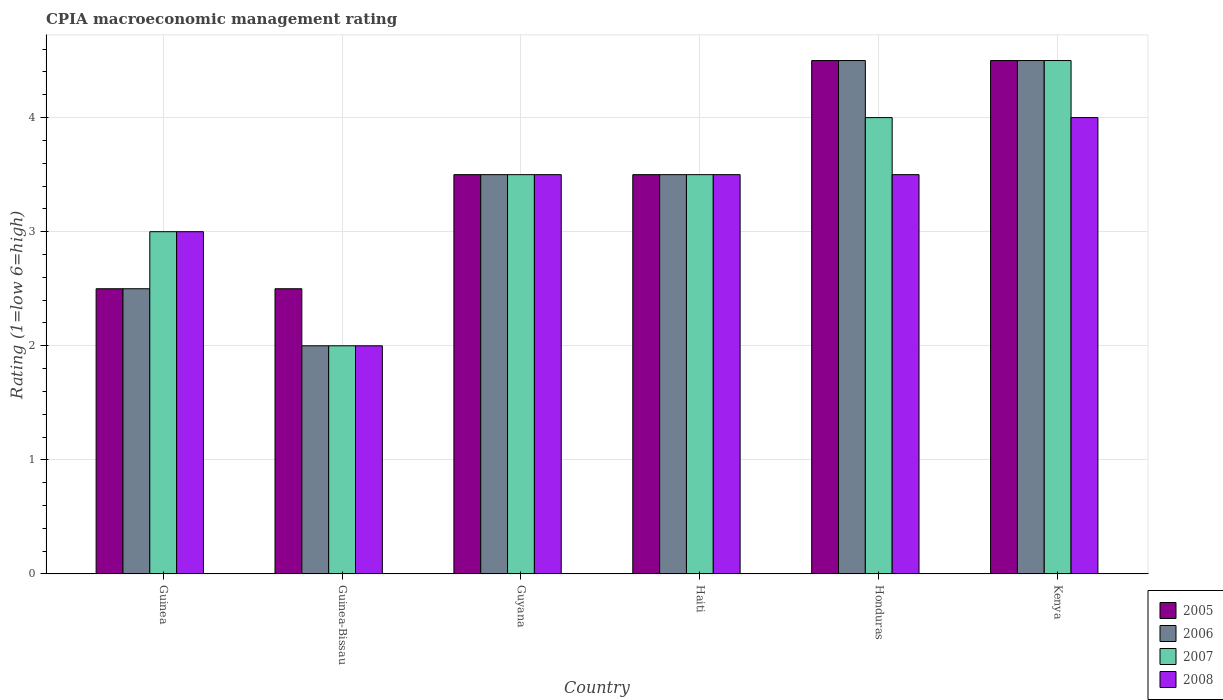Are the number of bars per tick equal to the number of legend labels?
Ensure brevity in your answer.  Yes. Are the number of bars on each tick of the X-axis equal?
Your response must be concise. Yes. What is the label of the 1st group of bars from the left?
Your answer should be very brief. Guinea. In how many cases, is the number of bars for a given country not equal to the number of legend labels?
Make the answer very short. 0. What is the CPIA rating in 2006 in Guinea-Bissau?
Your response must be concise. 2. Across all countries, what is the maximum CPIA rating in 2006?
Your answer should be very brief. 4.5. In which country was the CPIA rating in 2007 maximum?
Your answer should be very brief. Kenya. In which country was the CPIA rating in 2006 minimum?
Make the answer very short. Guinea-Bissau. What is the total CPIA rating in 2005 in the graph?
Offer a terse response. 21. What is the average CPIA rating in 2006 per country?
Make the answer very short. 3.42. In how many countries, is the CPIA rating in 2006 greater than 2?
Make the answer very short. 5. What is the ratio of the CPIA rating in 2005 in Haiti to that in Honduras?
Your answer should be compact. 0.78. Is the CPIA rating in 2008 in Guyana less than that in Kenya?
Ensure brevity in your answer.  Yes. Is the sum of the CPIA rating in 2007 in Guinea-Bissau and Guyana greater than the maximum CPIA rating in 2008 across all countries?
Provide a short and direct response. Yes. What does the 3rd bar from the left in Guyana represents?
Ensure brevity in your answer.  2007. What does the 3rd bar from the right in Guinea represents?
Give a very brief answer. 2006. Are all the bars in the graph horizontal?
Your answer should be very brief. No. Does the graph contain any zero values?
Provide a short and direct response. No. What is the title of the graph?
Your answer should be compact. CPIA macroeconomic management rating. Does "1999" appear as one of the legend labels in the graph?
Your response must be concise. No. What is the label or title of the X-axis?
Keep it short and to the point. Country. What is the Rating (1=low 6=high) of 2007 in Guinea?
Offer a terse response. 3. What is the Rating (1=low 6=high) of 2008 in Guinea?
Provide a succinct answer. 3. What is the Rating (1=low 6=high) of 2005 in Guinea-Bissau?
Give a very brief answer. 2.5. What is the Rating (1=low 6=high) of 2006 in Guinea-Bissau?
Your answer should be very brief. 2. What is the Rating (1=low 6=high) in 2007 in Guinea-Bissau?
Provide a succinct answer. 2. What is the Rating (1=low 6=high) in 2008 in Guinea-Bissau?
Keep it short and to the point. 2. What is the Rating (1=low 6=high) in 2005 in Guyana?
Provide a short and direct response. 3.5. What is the Rating (1=low 6=high) in 2006 in Guyana?
Give a very brief answer. 3.5. What is the Rating (1=low 6=high) in 2007 in Guyana?
Give a very brief answer. 3.5. What is the Rating (1=low 6=high) in 2008 in Guyana?
Your answer should be very brief. 3.5. What is the Rating (1=low 6=high) in 2008 in Haiti?
Keep it short and to the point. 3.5. What is the Rating (1=low 6=high) in 2005 in Honduras?
Give a very brief answer. 4.5. What is the Rating (1=low 6=high) of 2006 in Honduras?
Give a very brief answer. 4.5. What is the Rating (1=low 6=high) in 2005 in Kenya?
Offer a terse response. 4.5. What is the Rating (1=low 6=high) of 2007 in Kenya?
Offer a very short reply. 4.5. What is the Rating (1=low 6=high) of 2008 in Kenya?
Your response must be concise. 4. Across all countries, what is the minimum Rating (1=low 6=high) in 2005?
Offer a very short reply. 2.5. Across all countries, what is the minimum Rating (1=low 6=high) in 2007?
Your response must be concise. 2. Across all countries, what is the minimum Rating (1=low 6=high) of 2008?
Your answer should be compact. 2. What is the total Rating (1=low 6=high) of 2005 in the graph?
Your answer should be very brief. 21. What is the total Rating (1=low 6=high) of 2007 in the graph?
Ensure brevity in your answer.  20.5. What is the difference between the Rating (1=low 6=high) in 2005 in Guinea and that in Guinea-Bissau?
Keep it short and to the point. 0. What is the difference between the Rating (1=low 6=high) in 2006 in Guinea and that in Guyana?
Keep it short and to the point. -1. What is the difference between the Rating (1=low 6=high) in 2008 in Guinea and that in Guyana?
Your answer should be very brief. -0.5. What is the difference between the Rating (1=low 6=high) in 2007 in Guinea and that in Haiti?
Your response must be concise. -0.5. What is the difference between the Rating (1=low 6=high) in 2008 in Guinea and that in Haiti?
Give a very brief answer. -0.5. What is the difference between the Rating (1=low 6=high) of 2005 in Guinea and that in Honduras?
Offer a terse response. -2. What is the difference between the Rating (1=low 6=high) of 2007 in Guinea and that in Honduras?
Your answer should be very brief. -1. What is the difference between the Rating (1=low 6=high) in 2005 in Guinea and that in Kenya?
Your response must be concise. -2. What is the difference between the Rating (1=low 6=high) in 2008 in Guinea and that in Kenya?
Offer a very short reply. -1. What is the difference between the Rating (1=low 6=high) of 2005 in Guinea-Bissau and that in Haiti?
Make the answer very short. -1. What is the difference between the Rating (1=low 6=high) of 2006 in Guinea-Bissau and that in Haiti?
Give a very brief answer. -1.5. What is the difference between the Rating (1=low 6=high) in 2007 in Guinea-Bissau and that in Haiti?
Provide a succinct answer. -1.5. What is the difference between the Rating (1=low 6=high) of 2005 in Guinea-Bissau and that in Honduras?
Provide a succinct answer. -2. What is the difference between the Rating (1=low 6=high) in 2005 in Guinea-Bissau and that in Kenya?
Offer a very short reply. -2. What is the difference between the Rating (1=low 6=high) in 2006 in Guinea-Bissau and that in Kenya?
Ensure brevity in your answer.  -2.5. What is the difference between the Rating (1=low 6=high) in 2005 in Guyana and that in Haiti?
Your response must be concise. 0. What is the difference between the Rating (1=low 6=high) of 2006 in Guyana and that in Haiti?
Ensure brevity in your answer.  0. What is the difference between the Rating (1=low 6=high) in 2008 in Guyana and that in Haiti?
Offer a terse response. 0. What is the difference between the Rating (1=low 6=high) of 2005 in Guyana and that in Honduras?
Your answer should be compact. -1. What is the difference between the Rating (1=low 6=high) in 2008 in Guyana and that in Honduras?
Keep it short and to the point. 0. What is the difference between the Rating (1=low 6=high) in 2005 in Guyana and that in Kenya?
Your response must be concise. -1. What is the difference between the Rating (1=low 6=high) in 2006 in Guyana and that in Kenya?
Keep it short and to the point. -1. What is the difference between the Rating (1=low 6=high) in 2006 in Haiti and that in Honduras?
Provide a short and direct response. -1. What is the difference between the Rating (1=low 6=high) of 2007 in Haiti and that in Honduras?
Provide a succinct answer. -0.5. What is the difference between the Rating (1=low 6=high) of 2005 in Haiti and that in Kenya?
Offer a very short reply. -1. What is the difference between the Rating (1=low 6=high) of 2007 in Haiti and that in Kenya?
Your answer should be very brief. -1. What is the difference between the Rating (1=low 6=high) of 2008 in Haiti and that in Kenya?
Your answer should be compact. -0.5. What is the difference between the Rating (1=low 6=high) in 2005 in Honduras and that in Kenya?
Ensure brevity in your answer.  0. What is the difference between the Rating (1=low 6=high) in 2007 in Honduras and that in Kenya?
Provide a short and direct response. -0.5. What is the difference between the Rating (1=low 6=high) in 2008 in Honduras and that in Kenya?
Ensure brevity in your answer.  -0.5. What is the difference between the Rating (1=low 6=high) in 2005 in Guinea and the Rating (1=low 6=high) in 2006 in Guinea-Bissau?
Ensure brevity in your answer.  0.5. What is the difference between the Rating (1=low 6=high) of 2005 in Guinea and the Rating (1=low 6=high) of 2008 in Guyana?
Your answer should be very brief. -1. What is the difference between the Rating (1=low 6=high) in 2006 in Guinea and the Rating (1=low 6=high) in 2008 in Guyana?
Your response must be concise. -1. What is the difference between the Rating (1=low 6=high) of 2005 in Guinea and the Rating (1=low 6=high) of 2006 in Haiti?
Your answer should be very brief. -1. What is the difference between the Rating (1=low 6=high) in 2006 in Guinea and the Rating (1=low 6=high) in 2008 in Haiti?
Offer a terse response. -1. What is the difference between the Rating (1=low 6=high) in 2007 in Guinea and the Rating (1=low 6=high) in 2008 in Haiti?
Make the answer very short. -0.5. What is the difference between the Rating (1=low 6=high) in 2005 in Guinea and the Rating (1=low 6=high) in 2008 in Honduras?
Your answer should be compact. -1. What is the difference between the Rating (1=low 6=high) of 2006 in Guinea and the Rating (1=low 6=high) of 2007 in Honduras?
Your response must be concise. -1.5. What is the difference between the Rating (1=low 6=high) of 2005 in Guinea and the Rating (1=low 6=high) of 2006 in Kenya?
Provide a short and direct response. -2. What is the difference between the Rating (1=low 6=high) in 2005 in Guinea and the Rating (1=low 6=high) in 2007 in Kenya?
Give a very brief answer. -2. What is the difference between the Rating (1=low 6=high) in 2005 in Guinea and the Rating (1=low 6=high) in 2008 in Kenya?
Provide a succinct answer. -1.5. What is the difference between the Rating (1=low 6=high) in 2006 in Guinea and the Rating (1=low 6=high) in 2008 in Kenya?
Give a very brief answer. -1.5. What is the difference between the Rating (1=low 6=high) of 2007 in Guinea and the Rating (1=low 6=high) of 2008 in Kenya?
Make the answer very short. -1. What is the difference between the Rating (1=low 6=high) of 2005 in Guinea-Bissau and the Rating (1=low 6=high) of 2007 in Guyana?
Keep it short and to the point. -1. What is the difference between the Rating (1=low 6=high) in 2006 in Guinea-Bissau and the Rating (1=low 6=high) in 2007 in Guyana?
Give a very brief answer. -1.5. What is the difference between the Rating (1=low 6=high) of 2006 in Guinea-Bissau and the Rating (1=low 6=high) of 2008 in Guyana?
Make the answer very short. -1.5. What is the difference between the Rating (1=low 6=high) of 2005 in Guinea-Bissau and the Rating (1=low 6=high) of 2007 in Haiti?
Offer a very short reply. -1. What is the difference between the Rating (1=low 6=high) of 2006 in Guinea-Bissau and the Rating (1=low 6=high) of 2008 in Haiti?
Provide a succinct answer. -1.5. What is the difference between the Rating (1=low 6=high) of 2007 in Guinea-Bissau and the Rating (1=low 6=high) of 2008 in Haiti?
Provide a short and direct response. -1.5. What is the difference between the Rating (1=low 6=high) of 2005 in Guinea-Bissau and the Rating (1=low 6=high) of 2006 in Honduras?
Make the answer very short. -2. What is the difference between the Rating (1=low 6=high) in 2005 in Guinea-Bissau and the Rating (1=low 6=high) in 2008 in Honduras?
Make the answer very short. -1. What is the difference between the Rating (1=low 6=high) of 2006 in Guinea-Bissau and the Rating (1=low 6=high) of 2007 in Honduras?
Provide a succinct answer. -2. What is the difference between the Rating (1=low 6=high) of 2006 in Guinea-Bissau and the Rating (1=low 6=high) of 2008 in Honduras?
Offer a very short reply. -1.5. What is the difference between the Rating (1=low 6=high) in 2005 in Guinea-Bissau and the Rating (1=low 6=high) in 2007 in Kenya?
Keep it short and to the point. -2. What is the difference between the Rating (1=low 6=high) in 2006 in Guinea-Bissau and the Rating (1=low 6=high) in 2007 in Kenya?
Offer a terse response. -2.5. What is the difference between the Rating (1=low 6=high) in 2005 in Guyana and the Rating (1=low 6=high) in 2006 in Haiti?
Make the answer very short. 0. What is the difference between the Rating (1=low 6=high) of 2005 in Guyana and the Rating (1=low 6=high) of 2007 in Haiti?
Your answer should be very brief. 0. What is the difference between the Rating (1=low 6=high) in 2005 in Guyana and the Rating (1=low 6=high) in 2008 in Haiti?
Make the answer very short. 0. What is the difference between the Rating (1=low 6=high) of 2006 in Guyana and the Rating (1=low 6=high) of 2008 in Haiti?
Your answer should be very brief. 0. What is the difference between the Rating (1=low 6=high) of 2007 in Guyana and the Rating (1=low 6=high) of 2008 in Haiti?
Offer a terse response. 0. What is the difference between the Rating (1=low 6=high) of 2005 in Guyana and the Rating (1=low 6=high) of 2007 in Honduras?
Offer a terse response. -0.5. What is the difference between the Rating (1=low 6=high) in 2005 in Guyana and the Rating (1=low 6=high) in 2008 in Honduras?
Provide a succinct answer. 0. What is the difference between the Rating (1=low 6=high) of 2006 in Guyana and the Rating (1=low 6=high) of 2008 in Honduras?
Provide a succinct answer. 0. What is the difference between the Rating (1=low 6=high) in 2007 in Guyana and the Rating (1=low 6=high) in 2008 in Honduras?
Your answer should be compact. 0. What is the difference between the Rating (1=low 6=high) of 2005 in Guyana and the Rating (1=low 6=high) of 2007 in Kenya?
Your answer should be very brief. -1. What is the difference between the Rating (1=low 6=high) in 2005 in Guyana and the Rating (1=low 6=high) in 2008 in Kenya?
Give a very brief answer. -0.5. What is the difference between the Rating (1=low 6=high) in 2006 in Guyana and the Rating (1=low 6=high) in 2007 in Kenya?
Keep it short and to the point. -1. What is the difference between the Rating (1=low 6=high) in 2007 in Guyana and the Rating (1=low 6=high) in 2008 in Kenya?
Your answer should be compact. -0.5. What is the difference between the Rating (1=low 6=high) in 2005 in Haiti and the Rating (1=low 6=high) in 2008 in Honduras?
Keep it short and to the point. 0. What is the difference between the Rating (1=low 6=high) in 2006 in Haiti and the Rating (1=low 6=high) in 2007 in Honduras?
Ensure brevity in your answer.  -0.5. What is the difference between the Rating (1=low 6=high) in 2006 in Haiti and the Rating (1=low 6=high) in 2008 in Honduras?
Ensure brevity in your answer.  0. What is the difference between the Rating (1=low 6=high) in 2005 in Haiti and the Rating (1=low 6=high) in 2007 in Kenya?
Provide a succinct answer. -1. What is the difference between the Rating (1=low 6=high) in 2007 in Haiti and the Rating (1=low 6=high) in 2008 in Kenya?
Your response must be concise. -0.5. What is the difference between the Rating (1=low 6=high) of 2005 in Honduras and the Rating (1=low 6=high) of 2006 in Kenya?
Keep it short and to the point. 0. What is the difference between the Rating (1=low 6=high) in 2005 in Honduras and the Rating (1=low 6=high) in 2007 in Kenya?
Make the answer very short. 0. What is the difference between the Rating (1=low 6=high) in 2005 in Honduras and the Rating (1=low 6=high) in 2008 in Kenya?
Keep it short and to the point. 0.5. What is the difference between the Rating (1=low 6=high) of 2006 in Honduras and the Rating (1=low 6=high) of 2007 in Kenya?
Give a very brief answer. 0. What is the difference between the Rating (1=low 6=high) in 2006 in Honduras and the Rating (1=low 6=high) in 2008 in Kenya?
Your answer should be very brief. 0.5. What is the average Rating (1=low 6=high) in 2006 per country?
Your answer should be compact. 3.42. What is the average Rating (1=low 6=high) in 2007 per country?
Make the answer very short. 3.42. What is the average Rating (1=low 6=high) of 2008 per country?
Your answer should be compact. 3.25. What is the difference between the Rating (1=low 6=high) of 2005 and Rating (1=low 6=high) of 2006 in Guinea?
Your answer should be compact. 0. What is the difference between the Rating (1=low 6=high) of 2005 and Rating (1=low 6=high) of 2007 in Guinea?
Provide a succinct answer. -0.5. What is the difference between the Rating (1=low 6=high) of 2005 and Rating (1=low 6=high) of 2008 in Guinea?
Your response must be concise. -0.5. What is the difference between the Rating (1=low 6=high) in 2006 and Rating (1=low 6=high) in 2007 in Guinea?
Provide a succinct answer. -0.5. What is the difference between the Rating (1=low 6=high) in 2006 and Rating (1=low 6=high) in 2008 in Guinea?
Give a very brief answer. -0.5. What is the difference between the Rating (1=low 6=high) in 2007 and Rating (1=low 6=high) in 2008 in Guinea?
Ensure brevity in your answer.  0. What is the difference between the Rating (1=low 6=high) in 2005 and Rating (1=low 6=high) in 2006 in Guyana?
Give a very brief answer. 0. What is the difference between the Rating (1=low 6=high) in 2005 and Rating (1=low 6=high) in 2007 in Guyana?
Provide a succinct answer. 0. What is the difference between the Rating (1=low 6=high) in 2005 and Rating (1=low 6=high) in 2008 in Guyana?
Keep it short and to the point. 0. What is the difference between the Rating (1=low 6=high) in 2007 and Rating (1=low 6=high) in 2008 in Guyana?
Ensure brevity in your answer.  0. What is the difference between the Rating (1=low 6=high) of 2005 and Rating (1=low 6=high) of 2006 in Haiti?
Ensure brevity in your answer.  0. What is the difference between the Rating (1=low 6=high) in 2005 and Rating (1=low 6=high) in 2007 in Haiti?
Your answer should be compact. 0. What is the difference between the Rating (1=low 6=high) of 2005 and Rating (1=low 6=high) of 2008 in Haiti?
Your answer should be compact. 0. What is the difference between the Rating (1=low 6=high) in 2006 and Rating (1=low 6=high) in 2007 in Haiti?
Provide a short and direct response. 0. What is the difference between the Rating (1=low 6=high) in 2006 and Rating (1=low 6=high) in 2008 in Haiti?
Your answer should be very brief. 0. What is the difference between the Rating (1=low 6=high) in 2005 and Rating (1=low 6=high) in 2007 in Honduras?
Make the answer very short. 0.5. What is the difference between the Rating (1=low 6=high) of 2005 and Rating (1=low 6=high) of 2008 in Honduras?
Your response must be concise. 1. What is the difference between the Rating (1=low 6=high) of 2006 and Rating (1=low 6=high) of 2008 in Honduras?
Your answer should be compact. 1. What is the difference between the Rating (1=low 6=high) in 2005 and Rating (1=low 6=high) in 2007 in Kenya?
Make the answer very short. 0. What is the difference between the Rating (1=low 6=high) of 2005 and Rating (1=low 6=high) of 2008 in Kenya?
Your answer should be very brief. 0.5. What is the difference between the Rating (1=low 6=high) of 2006 and Rating (1=low 6=high) of 2008 in Kenya?
Keep it short and to the point. 0.5. What is the difference between the Rating (1=low 6=high) of 2007 and Rating (1=low 6=high) of 2008 in Kenya?
Provide a succinct answer. 0.5. What is the ratio of the Rating (1=low 6=high) of 2006 in Guinea to that in Guinea-Bissau?
Your answer should be compact. 1.25. What is the ratio of the Rating (1=low 6=high) in 2008 in Guinea to that in Guinea-Bissau?
Make the answer very short. 1.5. What is the ratio of the Rating (1=low 6=high) of 2005 in Guinea to that in Guyana?
Provide a succinct answer. 0.71. What is the ratio of the Rating (1=low 6=high) in 2007 in Guinea to that in Guyana?
Offer a very short reply. 0.86. What is the ratio of the Rating (1=low 6=high) in 2008 in Guinea to that in Haiti?
Make the answer very short. 0.86. What is the ratio of the Rating (1=low 6=high) in 2005 in Guinea to that in Honduras?
Give a very brief answer. 0.56. What is the ratio of the Rating (1=low 6=high) of 2006 in Guinea to that in Honduras?
Ensure brevity in your answer.  0.56. What is the ratio of the Rating (1=low 6=high) of 2007 in Guinea to that in Honduras?
Offer a terse response. 0.75. What is the ratio of the Rating (1=low 6=high) of 2008 in Guinea to that in Honduras?
Keep it short and to the point. 0.86. What is the ratio of the Rating (1=low 6=high) of 2005 in Guinea to that in Kenya?
Ensure brevity in your answer.  0.56. What is the ratio of the Rating (1=low 6=high) of 2006 in Guinea to that in Kenya?
Provide a short and direct response. 0.56. What is the ratio of the Rating (1=low 6=high) of 2005 in Guinea-Bissau to that in Guyana?
Provide a succinct answer. 0.71. What is the ratio of the Rating (1=low 6=high) of 2005 in Guinea-Bissau to that in Haiti?
Your response must be concise. 0.71. What is the ratio of the Rating (1=low 6=high) of 2008 in Guinea-Bissau to that in Haiti?
Make the answer very short. 0.57. What is the ratio of the Rating (1=low 6=high) of 2005 in Guinea-Bissau to that in Honduras?
Offer a very short reply. 0.56. What is the ratio of the Rating (1=low 6=high) of 2006 in Guinea-Bissau to that in Honduras?
Offer a very short reply. 0.44. What is the ratio of the Rating (1=low 6=high) of 2008 in Guinea-Bissau to that in Honduras?
Keep it short and to the point. 0.57. What is the ratio of the Rating (1=low 6=high) in 2005 in Guinea-Bissau to that in Kenya?
Ensure brevity in your answer.  0.56. What is the ratio of the Rating (1=low 6=high) in 2006 in Guinea-Bissau to that in Kenya?
Your answer should be compact. 0.44. What is the ratio of the Rating (1=low 6=high) of 2007 in Guinea-Bissau to that in Kenya?
Offer a very short reply. 0.44. What is the ratio of the Rating (1=low 6=high) in 2008 in Guinea-Bissau to that in Kenya?
Your answer should be compact. 0.5. What is the ratio of the Rating (1=low 6=high) in 2007 in Guyana to that in Haiti?
Your answer should be very brief. 1. What is the ratio of the Rating (1=low 6=high) of 2005 in Guyana to that in Honduras?
Ensure brevity in your answer.  0.78. What is the ratio of the Rating (1=low 6=high) in 2007 in Guyana to that in Honduras?
Offer a very short reply. 0.88. What is the ratio of the Rating (1=low 6=high) in 2005 in Guyana to that in Kenya?
Offer a very short reply. 0.78. What is the ratio of the Rating (1=low 6=high) in 2007 in Guyana to that in Kenya?
Make the answer very short. 0.78. What is the ratio of the Rating (1=low 6=high) in 2005 in Haiti to that in Honduras?
Offer a terse response. 0.78. What is the ratio of the Rating (1=low 6=high) of 2006 in Haiti to that in Honduras?
Make the answer very short. 0.78. What is the ratio of the Rating (1=low 6=high) in 2005 in Haiti to that in Kenya?
Provide a succinct answer. 0.78. What is the ratio of the Rating (1=low 6=high) in 2006 in Haiti to that in Kenya?
Your answer should be compact. 0.78. What is the ratio of the Rating (1=low 6=high) in 2005 in Honduras to that in Kenya?
Offer a very short reply. 1. What is the ratio of the Rating (1=low 6=high) of 2006 in Honduras to that in Kenya?
Make the answer very short. 1. What is the difference between the highest and the lowest Rating (1=low 6=high) of 2006?
Provide a succinct answer. 2.5. What is the difference between the highest and the lowest Rating (1=low 6=high) in 2007?
Your answer should be very brief. 2.5. What is the difference between the highest and the lowest Rating (1=low 6=high) of 2008?
Your response must be concise. 2. 